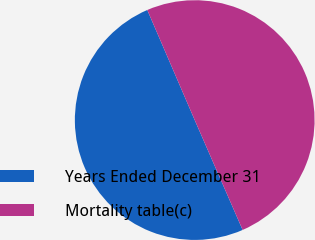<chart> <loc_0><loc_0><loc_500><loc_500><pie_chart><fcel>Years Ended December 31<fcel>Mortality table(c)<nl><fcel>50.07%<fcel>49.93%<nl></chart> 